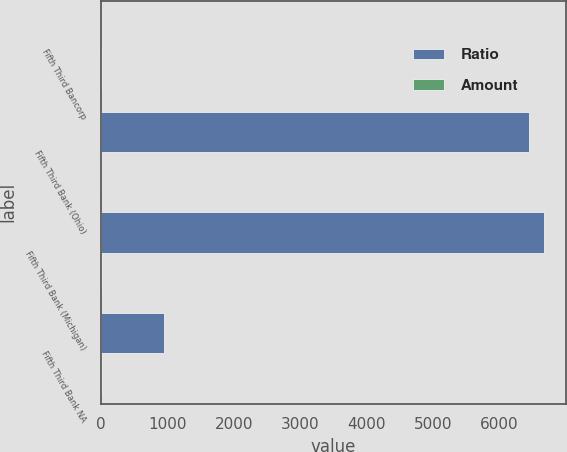Convert chart. <chart><loc_0><loc_0><loc_500><loc_500><stacked_bar_chart><ecel><fcel>Fifth Third Bancorp<fcel>Fifth Third Bank (Ohio)<fcel>Fifth Third Bank (Michigan)<fcel>Fifth Third Bank NA<nl><fcel>Ratio<fcel>17.59<fcel>6444<fcel>6664<fcel>948<nl><fcel>Amount<fcel>14.78<fcel>10.92<fcel>12.95<fcel>17.59<nl></chart> 